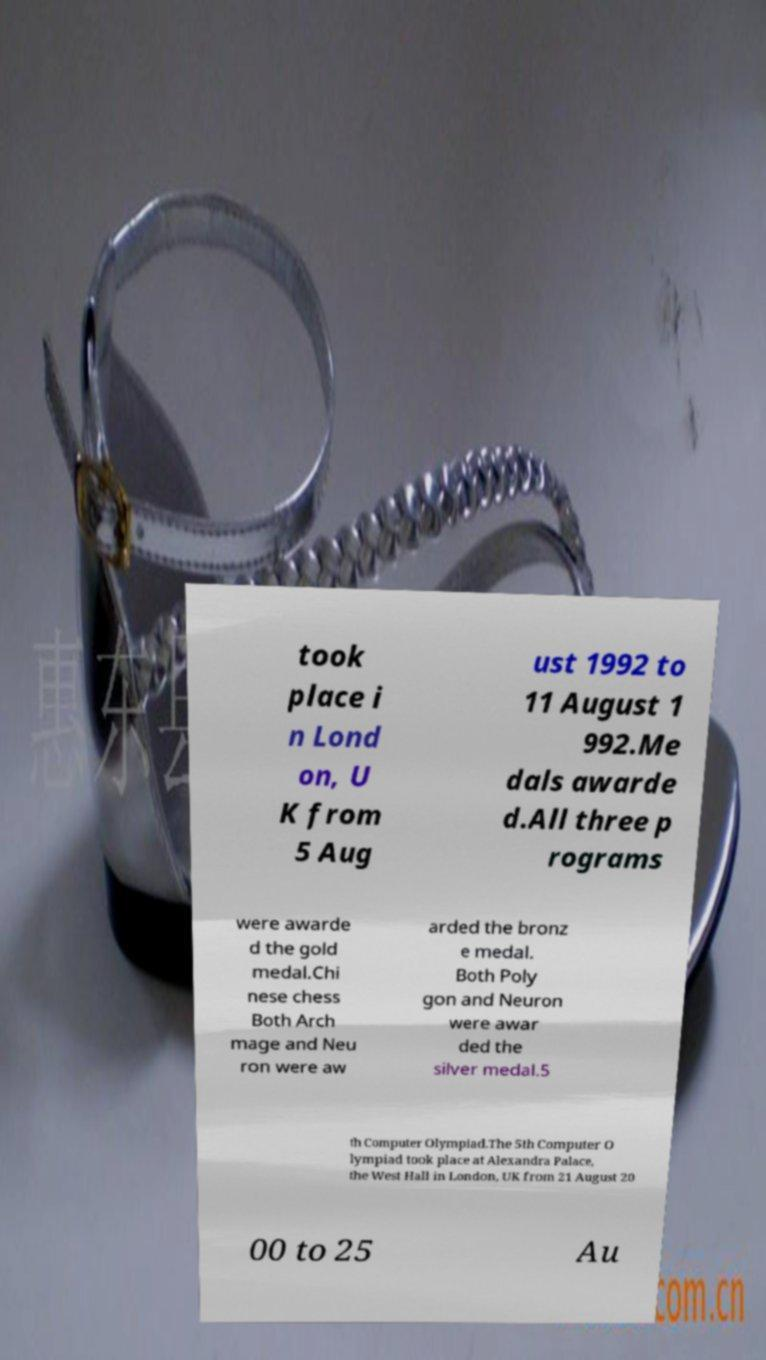Can you read and provide the text displayed in the image?This photo seems to have some interesting text. Can you extract and type it out for me? took place i n Lond on, U K from 5 Aug ust 1992 to 11 August 1 992.Me dals awarde d.All three p rograms were awarde d the gold medal.Chi nese chess Both Arch mage and Neu ron were aw arded the bronz e medal. Both Poly gon and Neuron were awar ded the silver medal.5 th Computer Olympiad.The 5th Computer O lympiad took place at Alexandra Palace, the West Hall in London, UK from 21 August 20 00 to 25 Au 